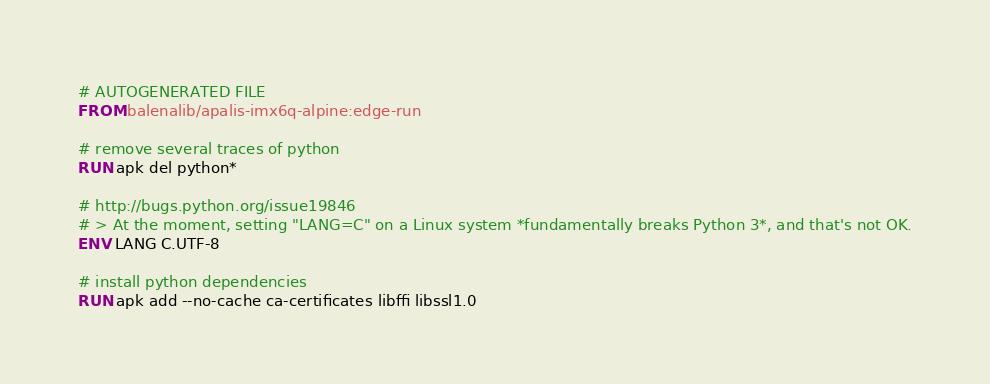Convert code to text. <code><loc_0><loc_0><loc_500><loc_500><_Dockerfile_># AUTOGENERATED FILE
FROM balenalib/apalis-imx6q-alpine:edge-run

# remove several traces of python
RUN apk del python*

# http://bugs.python.org/issue19846
# > At the moment, setting "LANG=C" on a Linux system *fundamentally breaks Python 3*, and that's not OK.
ENV LANG C.UTF-8

# install python dependencies
RUN apk add --no-cache ca-certificates libffi libssl1.0
</code> 